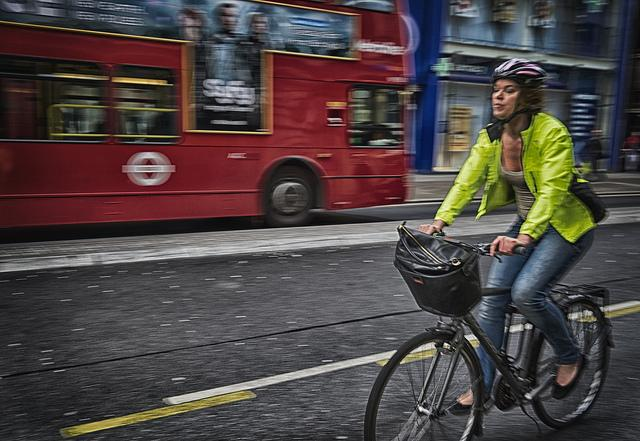What allows the woman on the bike to carry needed items safely? basket 